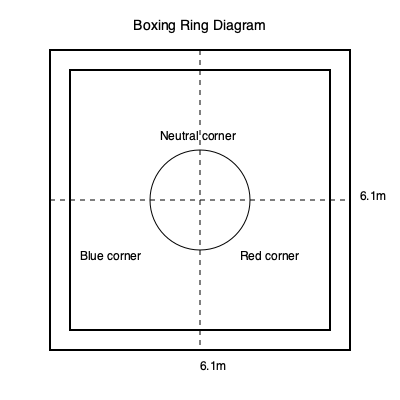In a standard professional boxing ring, what is the dimension of the inner square formed by the ropes, and what is the name of the central circular area where boxers touch gloves before the fight? To answer this question, let's break down the key elements of a standard professional boxing ring:

1. The outer square:
   - The outer square of the ring is typically 6.1 meters (20 feet) on each side.
   - This is represented by the outermost square in the diagram.

2. The inner square:
   - The inner square is formed by the ropes and is slightly smaller than the outer square.
   - It measures 5.5 meters (18 feet) on each side.
   - This is represented by the inner square in the diagram.

3. The central circular area:
   - In the center of the ring, there is a circular area.
   - This area is called the "neutral zone" or "center ring."
   - It's where the boxers meet to touch gloves before the fight begins and where the referee gives instructions.
   - The diameter of this circle is typically about 1 meter (3 feet).

4. Corners:
   - The ring has four corners: two neutral corners and two colored corners (red and blue).
   - The colored corners are where the boxers return between rounds.

The question specifically asks about the dimension of the inner square and the name of the central circular area. Based on our explanation:

- The inner square dimension is 5.5 meters (18 feet) on each side.
- The central circular area is called the "neutral zone" or "center ring."
Answer: 5.5 meters (18 feet); neutral zone 